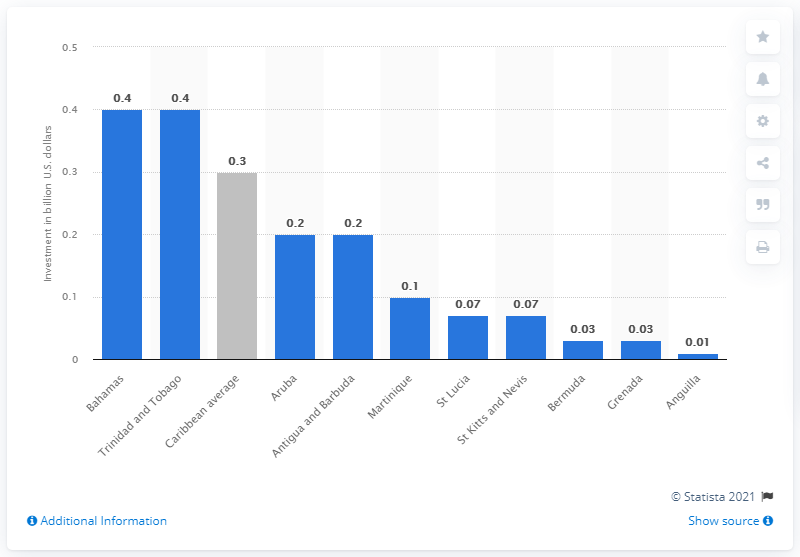Highlight a few significant elements in this photo. In 2017, an estimated $400 million was invested in the Bahamas' travel and tourism industry. 